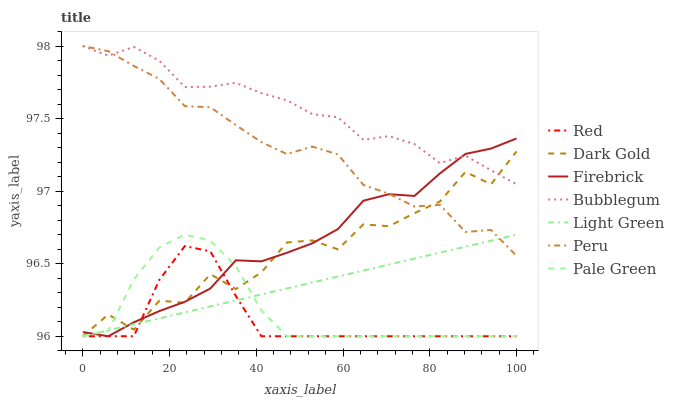Does Red have the minimum area under the curve?
Answer yes or no. Yes. Does Bubblegum have the maximum area under the curve?
Answer yes or no. Yes. Does Dark Gold have the minimum area under the curve?
Answer yes or no. No. Does Dark Gold have the maximum area under the curve?
Answer yes or no. No. Is Light Green the smoothest?
Answer yes or no. Yes. Is Dark Gold the roughest?
Answer yes or no. Yes. Is Firebrick the smoothest?
Answer yes or no. No. Is Firebrick the roughest?
Answer yes or no. No. Does Light Green have the lowest value?
Answer yes or no. Yes. Does Bubblegum have the lowest value?
Answer yes or no. No. Does Peru have the highest value?
Answer yes or no. Yes. Does Dark Gold have the highest value?
Answer yes or no. No. Is Red less than Peru?
Answer yes or no. Yes. Is Bubblegum greater than Pale Green?
Answer yes or no. Yes. Does Pale Green intersect Dark Gold?
Answer yes or no. Yes. Is Pale Green less than Dark Gold?
Answer yes or no. No. Is Pale Green greater than Dark Gold?
Answer yes or no. No. Does Red intersect Peru?
Answer yes or no. No. 